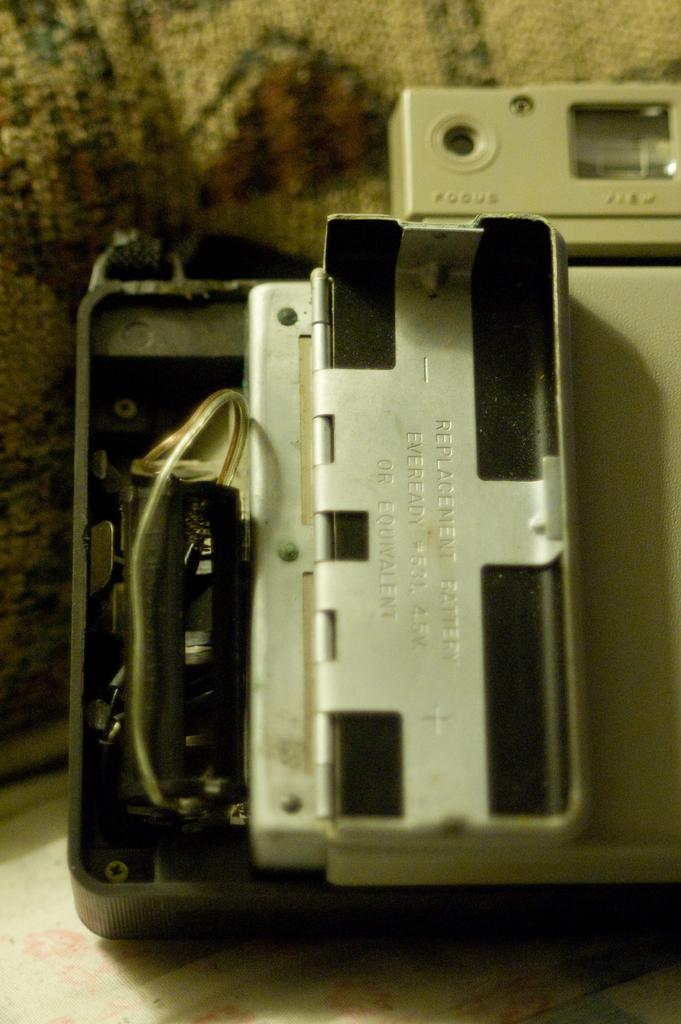How would you summarize this image in a sentence or two? In this image I can see backside of a camera and over here I can see something is written. 